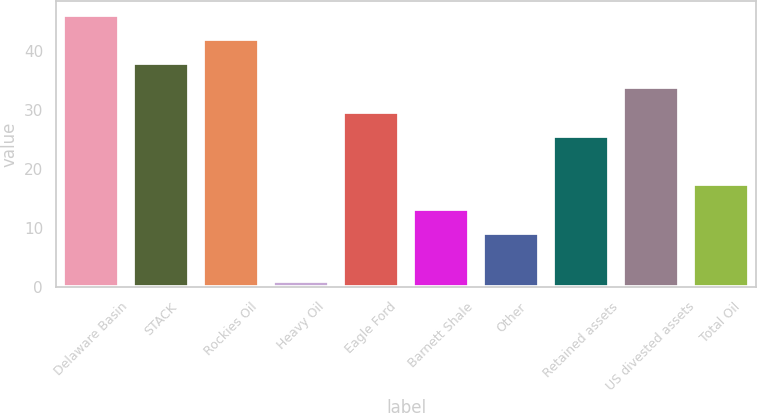<chart> <loc_0><loc_0><loc_500><loc_500><bar_chart><fcel>Delaware Basin<fcel>STACK<fcel>Rockies Oil<fcel>Heavy Oil<fcel>Eagle Ford<fcel>Barnett Shale<fcel>Other<fcel>Retained assets<fcel>US divested assets<fcel>Total Oil<nl><fcel>46.1<fcel>37.9<fcel>42<fcel>1<fcel>29.7<fcel>13.3<fcel>9.2<fcel>25.6<fcel>33.8<fcel>17.4<nl></chart> 